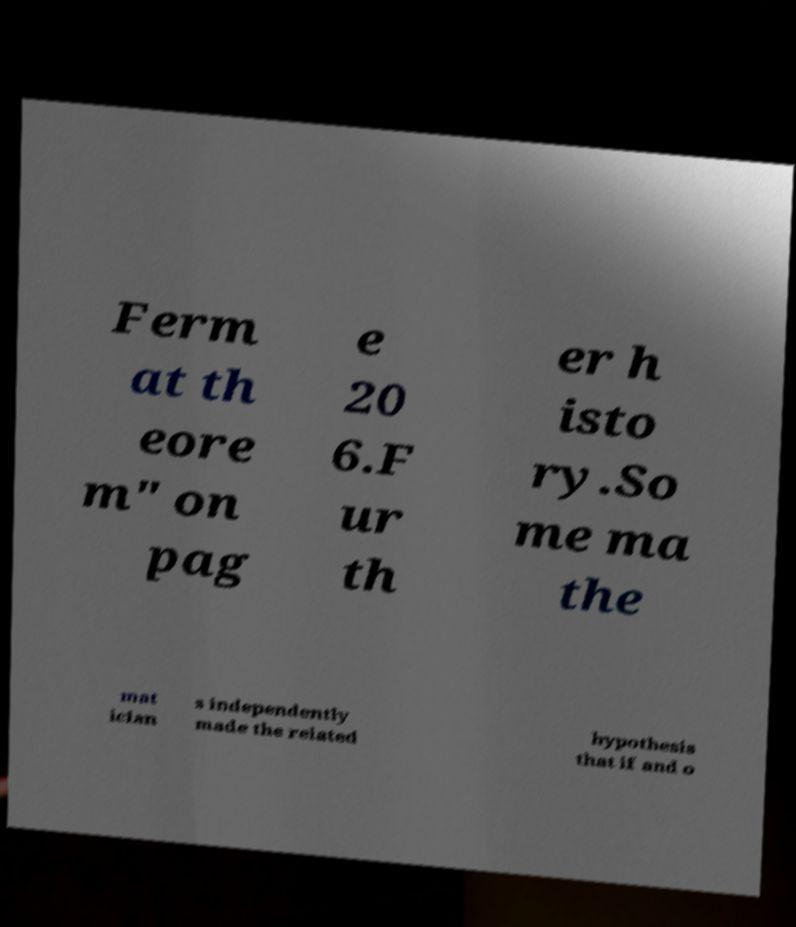Can you accurately transcribe the text from the provided image for me? Ferm at th eore m" on pag e 20 6.F ur th er h isto ry.So me ma the mat ician s independently made the related hypothesis that if and o 